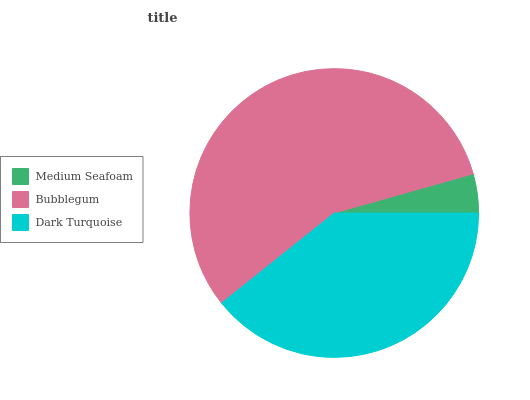Is Medium Seafoam the minimum?
Answer yes or no. Yes. Is Bubblegum the maximum?
Answer yes or no. Yes. Is Dark Turquoise the minimum?
Answer yes or no. No. Is Dark Turquoise the maximum?
Answer yes or no. No. Is Bubblegum greater than Dark Turquoise?
Answer yes or no. Yes. Is Dark Turquoise less than Bubblegum?
Answer yes or no. Yes. Is Dark Turquoise greater than Bubblegum?
Answer yes or no. No. Is Bubblegum less than Dark Turquoise?
Answer yes or no. No. Is Dark Turquoise the high median?
Answer yes or no. Yes. Is Dark Turquoise the low median?
Answer yes or no. Yes. Is Medium Seafoam the high median?
Answer yes or no. No. Is Bubblegum the low median?
Answer yes or no. No. 